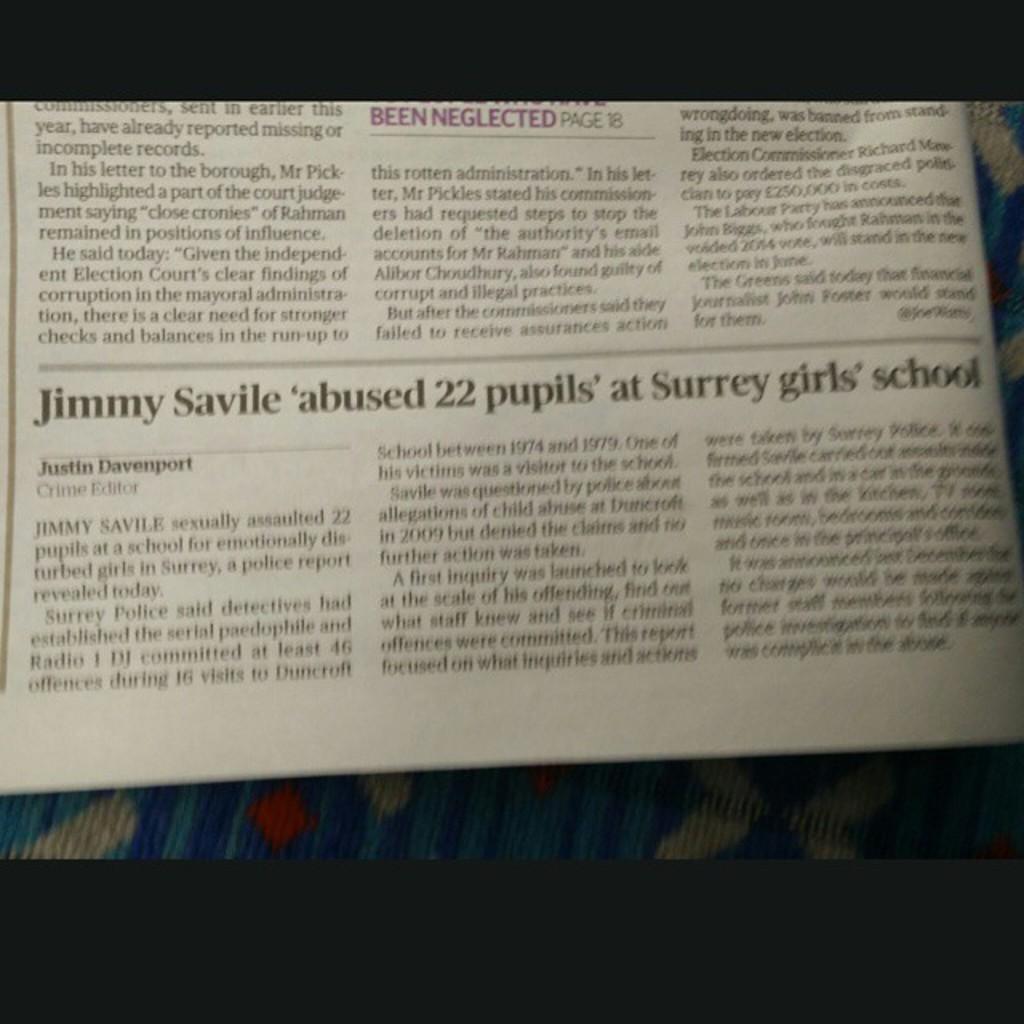How many pupils were abused?
Your answer should be compact. 22. Who abused the pupils?
Provide a succinct answer. Jimmy savile. 